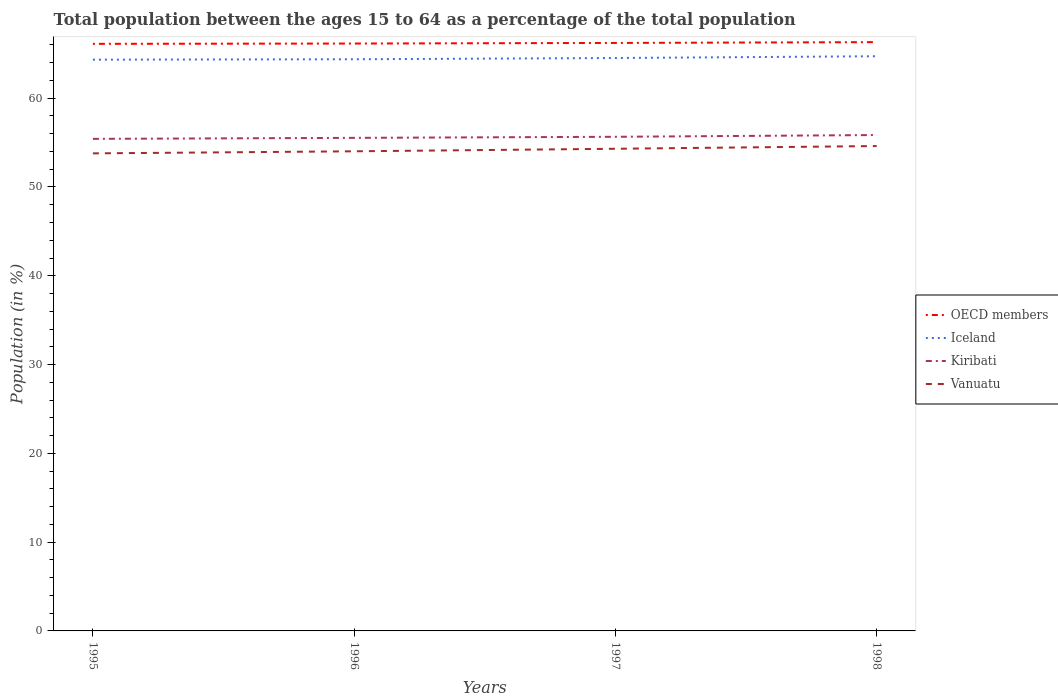How many different coloured lines are there?
Make the answer very short. 4. Does the line corresponding to Vanuatu intersect with the line corresponding to Kiribati?
Ensure brevity in your answer.  No. Across all years, what is the maximum percentage of the population ages 15 to 64 in Vanuatu?
Provide a short and direct response. 53.79. What is the total percentage of the population ages 15 to 64 in Kiribati in the graph?
Provide a short and direct response. -0.23. What is the difference between the highest and the second highest percentage of the population ages 15 to 64 in OECD members?
Your answer should be very brief. 0.19. Is the percentage of the population ages 15 to 64 in Iceland strictly greater than the percentage of the population ages 15 to 64 in OECD members over the years?
Provide a short and direct response. Yes. How many lines are there?
Ensure brevity in your answer.  4. How many years are there in the graph?
Your answer should be compact. 4. Where does the legend appear in the graph?
Your answer should be compact. Center right. How many legend labels are there?
Provide a succinct answer. 4. How are the legend labels stacked?
Ensure brevity in your answer.  Vertical. What is the title of the graph?
Make the answer very short. Total population between the ages 15 to 64 as a percentage of the total population. Does "Burkina Faso" appear as one of the legend labels in the graph?
Give a very brief answer. No. What is the label or title of the X-axis?
Provide a succinct answer. Years. What is the Population (in %) in OECD members in 1995?
Your answer should be very brief. 66.12. What is the Population (in %) of Iceland in 1995?
Keep it short and to the point. 64.34. What is the Population (in %) in Kiribati in 1995?
Make the answer very short. 55.42. What is the Population (in %) of Vanuatu in 1995?
Your response must be concise. 53.79. What is the Population (in %) in OECD members in 1996?
Provide a succinct answer. 66.15. What is the Population (in %) of Iceland in 1996?
Provide a short and direct response. 64.38. What is the Population (in %) in Kiribati in 1996?
Ensure brevity in your answer.  55.53. What is the Population (in %) in Vanuatu in 1996?
Offer a very short reply. 54.02. What is the Population (in %) of OECD members in 1997?
Provide a short and direct response. 66.22. What is the Population (in %) of Iceland in 1997?
Provide a succinct answer. 64.52. What is the Population (in %) in Kiribati in 1997?
Provide a short and direct response. 55.65. What is the Population (in %) of Vanuatu in 1997?
Your response must be concise. 54.3. What is the Population (in %) of OECD members in 1998?
Your answer should be compact. 66.31. What is the Population (in %) in Iceland in 1998?
Keep it short and to the point. 64.72. What is the Population (in %) in Kiribati in 1998?
Keep it short and to the point. 55.85. What is the Population (in %) in Vanuatu in 1998?
Ensure brevity in your answer.  54.61. Across all years, what is the maximum Population (in %) in OECD members?
Your answer should be compact. 66.31. Across all years, what is the maximum Population (in %) in Iceland?
Your response must be concise. 64.72. Across all years, what is the maximum Population (in %) in Kiribati?
Offer a very short reply. 55.85. Across all years, what is the maximum Population (in %) of Vanuatu?
Your answer should be compact. 54.61. Across all years, what is the minimum Population (in %) of OECD members?
Provide a short and direct response. 66.12. Across all years, what is the minimum Population (in %) in Iceland?
Your answer should be very brief. 64.34. Across all years, what is the minimum Population (in %) of Kiribati?
Keep it short and to the point. 55.42. Across all years, what is the minimum Population (in %) in Vanuatu?
Make the answer very short. 53.79. What is the total Population (in %) in OECD members in the graph?
Your answer should be compact. 264.81. What is the total Population (in %) in Iceland in the graph?
Make the answer very short. 257.97. What is the total Population (in %) of Kiribati in the graph?
Keep it short and to the point. 222.45. What is the total Population (in %) in Vanuatu in the graph?
Provide a succinct answer. 216.72. What is the difference between the Population (in %) of OECD members in 1995 and that in 1996?
Your answer should be very brief. -0.03. What is the difference between the Population (in %) of Iceland in 1995 and that in 1996?
Provide a succinct answer. -0.05. What is the difference between the Population (in %) in Kiribati in 1995 and that in 1996?
Your answer should be compact. -0.11. What is the difference between the Population (in %) in Vanuatu in 1995 and that in 1996?
Make the answer very short. -0.23. What is the difference between the Population (in %) in OECD members in 1995 and that in 1997?
Make the answer very short. -0.1. What is the difference between the Population (in %) in Iceland in 1995 and that in 1997?
Your response must be concise. -0.19. What is the difference between the Population (in %) in Kiribati in 1995 and that in 1997?
Keep it short and to the point. -0.23. What is the difference between the Population (in %) in Vanuatu in 1995 and that in 1997?
Your answer should be very brief. -0.52. What is the difference between the Population (in %) in OECD members in 1995 and that in 1998?
Provide a succinct answer. -0.19. What is the difference between the Population (in %) in Iceland in 1995 and that in 1998?
Your response must be concise. -0.39. What is the difference between the Population (in %) in Kiribati in 1995 and that in 1998?
Make the answer very short. -0.43. What is the difference between the Population (in %) in Vanuatu in 1995 and that in 1998?
Keep it short and to the point. -0.83. What is the difference between the Population (in %) in OECD members in 1996 and that in 1997?
Your answer should be compact. -0.07. What is the difference between the Population (in %) in Iceland in 1996 and that in 1997?
Give a very brief answer. -0.14. What is the difference between the Population (in %) of Kiribati in 1996 and that in 1997?
Keep it short and to the point. -0.12. What is the difference between the Population (in %) of Vanuatu in 1996 and that in 1997?
Your answer should be very brief. -0.29. What is the difference between the Population (in %) of OECD members in 1996 and that in 1998?
Offer a very short reply. -0.16. What is the difference between the Population (in %) in Iceland in 1996 and that in 1998?
Your answer should be compact. -0.34. What is the difference between the Population (in %) in Kiribati in 1996 and that in 1998?
Offer a terse response. -0.32. What is the difference between the Population (in %) of Vanuatu in 1996 and that in 1998?
Give a very brief answer. -0.59. What is the difference between the Population (in %) in OECD members in 1997 and that in 1998?
Your answer should be compact. -0.09. What is the difference between the Population (in %) of Iceland in 1997 and that in 1998?
Keep it short and to the point. -0.2. What is the difference between the Population (in %) in Kiribati in 1997 and that in 1998?
Provide a succinct answer. -0.2. What is the difference between the Population (in %) of Vanuatu in 1997 and that in 1998?
Offer a terse response. -0.31. What is the difference between the Population (in %) in OECD members in 1995 and the Population (in %) in Iceland in 1996?
Provide a short and direct response. 1.74. What is the difference between the Population (in %) of OECD members in 1995 and the Population (in %) of Kiribati in 1996?
Offer a terse response. 10.59. What is the difference between the Population (in %) of OECD members in 1995 and the Population (in %) of Vanuatu in 1996?
Make the answer very short. 12.1. What is the difference between the Population (in %) of Iceland in 1995 and the Population (in %) of Kiribati in 1996?
Give a very brief answer. 8.81. What is the difference between the Population (in %) in Iceland in 1995 and the Population (in %) in Vanuatu in 1996?
Provide a succinct answer. 10.32. What is the difference between the Population (in %) of Kiribati in 1995 and the Population (in %) of Vanuatu in 1996?
Give a very brief answer. 1.4. What is the difference between the Population (in %) of OECD members in 1995 and the Population (in %) of Iceland in 1997?
Your response must be concise. 1.6. What is the difference between the Population (in %) in OECD members in 1995 and the Population (in %) in Kiribati in 1997?
Give a very brief answer. 10.47. What is the difference between the Population (in %) of OECD members in 1995 and the Population (in %) of Vanuatu in 1997?
Your answer should be compact. 11.82. What is the difference between the Population (in %) in Iceland in 1995 and the Population (in %) in Kiribati in 1997?
Give a very brief answer. 8.69. What is the difference between the Population (in %) of Iceland in 1995 and the Population (in %) of Vanuatu in 1997?
Your answer should be very brief. 10.04. What is the difference between the Population (in %) in Kiribati in 1995 and the Population (in %) in Vanuatu in 1997?
Your response must be concise. 1.12. What is the difference between the Population (in %) of OECD members in 1995 and the Population (in %) of Iceland in 1998?
Provide a short and direct response. 1.4. What is the difference between the Population (in %) in OECD members in 1995 and the Population (in %) in Kiribati in 1998?
Make the answer very short. 10.27. What is the difference between the Population (in %) in OECD members in 1995 and the Population (in %) in Vanuatu in 1998?
Make the answer very short. 11.51. What is the difference between the Population (in %) of Iceland in 1995 and the Population (in %) of Kiribati in 1998?
Offer a terse response. 8.49. What is the difference between the Population (in %) in Iceland in 1995 and the Population (in %) in Vanuatu in 1998?
Your answer should be compact. 9.73. What is the difference between the Population (in %) of Kiribati in 1995 and the Population (in %) of Vanuatu in 1998?
Your answer should be very brief. 0.81. What is the difference between the Population (in %) in OECD members in 1996 and the Population (in %) in Iceland in 1997?
Your answer should be very brief. 1.63. What is the difference between the Population (in %) of OECD members in 1996 and the Population (in %) of Kiribati in 1997?
Give a very brief answer. 10.5. What is the difference between the Population (in %) in OECD members in 1996 and the Population (in %) in Vanuatu in 1997?
Give a very brief answer. 11.85. What is the difference between the Population (in %) in Iceland in 1996 and the Population (in %) in Kiribati in 1997?
Offer a very short reply. 8.73. What is the difference between the Population (in %) in Iceland in 1996 and the Population (in %) in Vanuatu in 1997?
Offer a terse response. 10.08. What is the difference between the Population (in %) of Kiribati in 1996 and the Population (in %) of Vanuatu in 1997?
Your answer should be compact. 1.23. What is the difference between the Population (in %) of OECD members in 1996 and the Population (in %) of Iceland in 1998?
Offer a very short reply. 1.43. What is the difference between the Population (in %) of OECD members in 1996 and the Population (in %) of Kiribati in 1998?
Give a very brief answer. 10.31. What is the difference between the Population (in %) in OECD members in 1996 and the Population (in %) in Vanuatu in 1998?
Offer a terse response. 11.54. What is the difference between the Population (in %) of Iceland in 1996 and the Population (in %) of Kiribati in 1998?
Offer a terse response. 8.54. What is the difference between the Population (in %) in Iceland in 1996 and the Population (in %) in Vanuatu in 1998?
Make the answer very short. 9.77. What is the difference between the Population (in %) of Kiribati in 1996 and the Population (in %) of Vanuatu in 1998?
Your answer should be very brief. 0.92. What is the difference between the Population (in %) of OECD members in 1997 and the Population (in %) of Iceland in 1998?
Make the answer very short. 1.5. What is the difference between the Population (in %) of OECD members in 1997 and the Population (in %) of Kiribati in 1998?
Make the answer very short. 10.37. What is the difference between the Population (in %) in OECD members in 1997 and the Population (in %) in Vanuatu in 1998?
Ensure brevity in your answer.  11.61. What is the difference between the Population (in %) in Iceland in 1997 and the Population (in %) in Kiribati in 1998?
Offer a terse response. 8.68. What is the difference between the Population (in %) in Iceland in 1997 and the Population (in %) in Vanuatu in 1998?
Ensure brevity in your answer.  9.91. What is the difference between the Population (in %) in Kiribati in 1997 and the Population (in %) in Vanuatu in 1998?
Give a very brief answer. 1.04. What is the average Population (in %) in OECD members per year?
Make the answer very short. 66.2. What is the average Population (in %) of Iceland per year?
Your answer should be compact. 64.49. What is the average Population (in %) of Kiribati per year?
Give a very brief answer. 55.61. What is the average Population (in %) in Vanuatu per year?
Your answer should be compact. 54.18. In the year 1995, what is the difference between the Population (in %) in OECD members and Population (in %) in Iceland?
Ensure brevity in your answer.  1.78. In the year 1995, what is the difference between the Population (in %) of OECD members and Population (in %) of Kiribati?
Keep it short and to the point. 10.7. In the year 1995, what is the difference between the Population (in %) of OECD members and Population (in %) of Vanuatu?
Offer a very short reply. 12.34. In the year 1995, what is the difference between the Population (in %) in Iceland and Population (in %) in Kiribati?
Make the answer very short. 8.92. In the year 1995, what is the difference between the Population (in %) in Iceland and Population (in %) in Vanuatu?
Your answer should be compact. 10.55. In the year 1995, what is the difference between the Population (in %) of Kiribati and Population (in %) of Vanuatu?
Your response must be concise. 1.63. In the year 1996, what is the difference between the Population (in %) in OECD members and Population (in %) in Iceland?
Offer a terse response. 1.77. In the year 1996, what is the difference between the Population (in %) in OECD members and Population (in %) in Kiribati?
Your answer should be very brief. 10.62. In the year 1996, what is the difference between the Population (in %) of OECD members and Population (in %) of Vanuatu?
Keep it short and to the point. 12.14. In the year 1996, what is the difference between the Population (in %) of Iceland and Population (in %) of Kiribati?
Offer a terse response. 8.85. In the year 1996, what is the difference between the Population (in %) in Iceland and Population (in %) in Vanuatu?
Ensure brevity in your answer.  10.37. In the year 1996, what is the difference between the Population (in %) of Kiribati and Population (in %) of Vanuatu?
Your answer should be very brief. 1.51. In the year 1997, what is the difference between the Population (in %) of OECD members and Population (in %) of Iceland?
Ensure brevity in your answer.  1.7. In the year 1997, what is the difference between the Population (in %) in OECD members and Population (in %) in Kiribati?
Provide a succinct answer. 10.57. In the year 1997, what is the difference between the Population (in %) in OECD members and Population (in %) in Vanuatu?
Your response must be concise. 11.92. In the year 1997, what is the difference between the Population (in %) of Iceland and Population (in %) of Kiribati?
Make the answer very short. 8.87. In the year 1997, what is the difference between the Population (in %) of Iceland and Population (in %) of Vanuatu?
Provide a succinct answer. 10.22. In the year 1997, what is the difference between the Population (in %) of Kiribati and Population (in %) of Vanuatu?
Keep it short and to the point. 1.35. In the year 1998, what is the difference between the Population (in %) in OECD members and Population (in %) in Iceland?
Your response must be concise. 1.59. In the year 1998, what is the difference between the Population (in %) in OECD members and Population (in %) in Kiribati?
Ensure brevity in your answer.  10.46. In the year 1998, what is the difference between the Population (in %) of OECD members and Population (in %) of Vanuatu?
Ensure brevity in your answer.  11.7. In the year 1998, what is the difference between the Population (in %) of Iceland and Population (in %) of Kiribati?
Offer a terse response. 8.88. In the year 1998, what is the difference between the Population (in %) in Iceland and Population (in %) in Vanuatu?
Provide a succinct answer. 10.11. In the year 1998, what is the difference between the Population (in %) in Kiribati and Population (in %) in Vanuatu?
Offer a very short reply. 1.24. What is the ratio of the Population (in %) of OECD members in 1995 to that in 1996?
Your response must be concise. 1. What is the ratio of the Population (in %) in Iceland in 1995 to that in 1996?
Offer a very short reply. 1. What is the ratio of the Population (in %) in Kiribati in 1995 to that in 1996?
Your answer should be very brief. 1. What is the ratio of the Population (in %) of Vanuatu in 1995 to that in 1996?
Offer a very short reply. 1. What is the ratio of the Population (in %) in OECD members in 1995 to that in 1997?
Offer a very short reply. 1. What is the ratio of the Population (in %) in Iceland in 1995 to that in 1997?
Your answer should be compact. 1. What is the ratio of the Population (in %) in Vanuatu in 1995 to that in 1997?
Offer a very short reply. 0.99. What is the ratio of the Population (in %) of Iceland in 1995 to that in 1998?
Your answer should be compact. 0.99. What is the ratio of the Population (in %) of Kiribati in 1995 to that in 1998?
Give a very brief answer. 0.99. What is the ratio of the Population (in %) of Vanuatu in 1995 to that in 1998?
Your response must be concise. 0.98. What is the ratio of the Population (in %) in OECD members in 1996 to that in 1997?
Give a very brief answer. 1. What is the ratio of the Population (in %) of Iceland in 1996 to that in 1997?
Your answer should be very brief. 1. What is the ratio of the Population (in %) of Kiribati in 1996 to that in 1997?
Your answer should be compact. 1. What is the ratio of the Population (in %) of Vanuatu in 1996 to that in 1997?
Offer a very short reply. 0.99. What is the ratio of the Population (in %) in OECD members in 1996 to that in 1998?
Ensure brevity in your answer.  1. What is the ratio of the Population (in %) in Iceland in 1996 to that in 1998?
Your answer should be very brief. 0.99. What is the ratio of the Population (in %) in Vanuatu in 1996 to that in 1998?
Offer a very short reply. 0.99. What is the ratio of the Population (in %) in Iceland in 1997 to that in 1998?
Your answer should be very brief. 1. What is the ratio of the Population (in %) in Kiribati in 1997 to that in 1998?
Offer a terse response. 1. What is the ratio of the Population (in %) in Vanuatu in 1997 to that in 1998?
Keep it short and to the point. 0.99. What is the difference between the highest and the second highest Population (in %) in OECD members?
Ensure brevity in your answer.  0.09. What is the difference between the highest and the second highest Population (in %) of Iceland?
Your response must be concise. 0.2. What is the difference between the highest and the second highest Population (in %) of Kiribati?
Offer a terse response. 0.2. What is the difference between the highest and the second highest Population (in %) of Vanuatu?
Make the answer very short. 0.31. What is the difference between the highest and the lowest Population (in %) of OECD members?
Make the answer very short. 0.19. What is the difference between the highest and the lowest Population (in %) of Iceland?
Provide a short and direct response. 0.39. What is the difference between the highest and the lowest Population (in %) in Kiribati?
Make the answer very short. 0.43. What is the difference between the highest and the lowest Population (in %) of Vanuatu?
Provide a short and direct response. 0.83. 